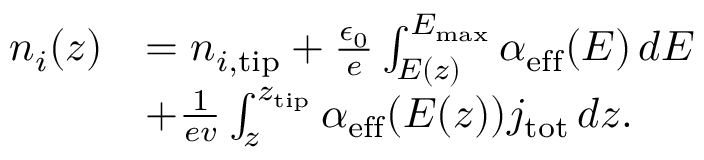Convert formula to latex. <formula><loc_0><loc_0><loc_500><loc_500>\begin{array} { r l } { n _ { i } ( z ) } & { = n _ { i , t i p } + \frac { \epsilon _ { 0 } } { e } \int _ { E ( z ) } ^ { E _ { \max } } \alpha _ { e f f } ( E ) \, d E } \\ & { + \frac { 1 } { e v } \int _ { z } ^ { z _ { t i p } } \alpha _ { e f f } ( E ( z ) ) j _ { t o t } \, d z . } \end{array}</formula> 